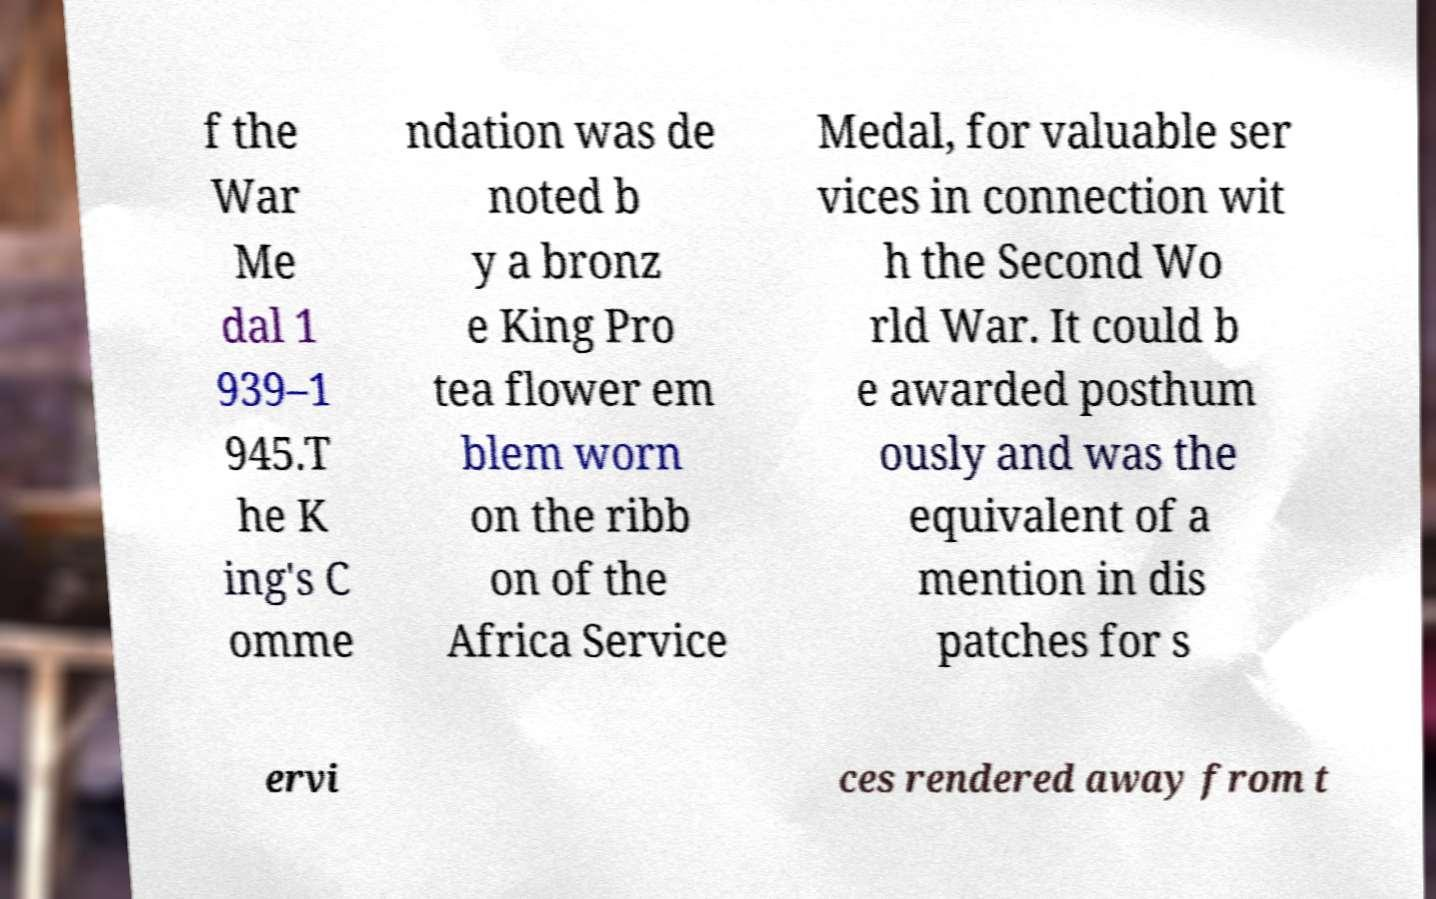What messages or text are displayed in this image? I need them in a readable, typed format. f the War Me dal 1 939–1 945.T he K ing's C omme ndation was de noted b y a bronz e King Pro tea flower em blem worn on the ribb on of the Africa Service Medal, for valuable ser vices in connection wit h the Second Wo rld War. It could b e awarded posthum ously and was the equivalent of a mention in dis patches for s ervi ces rendered away from t 